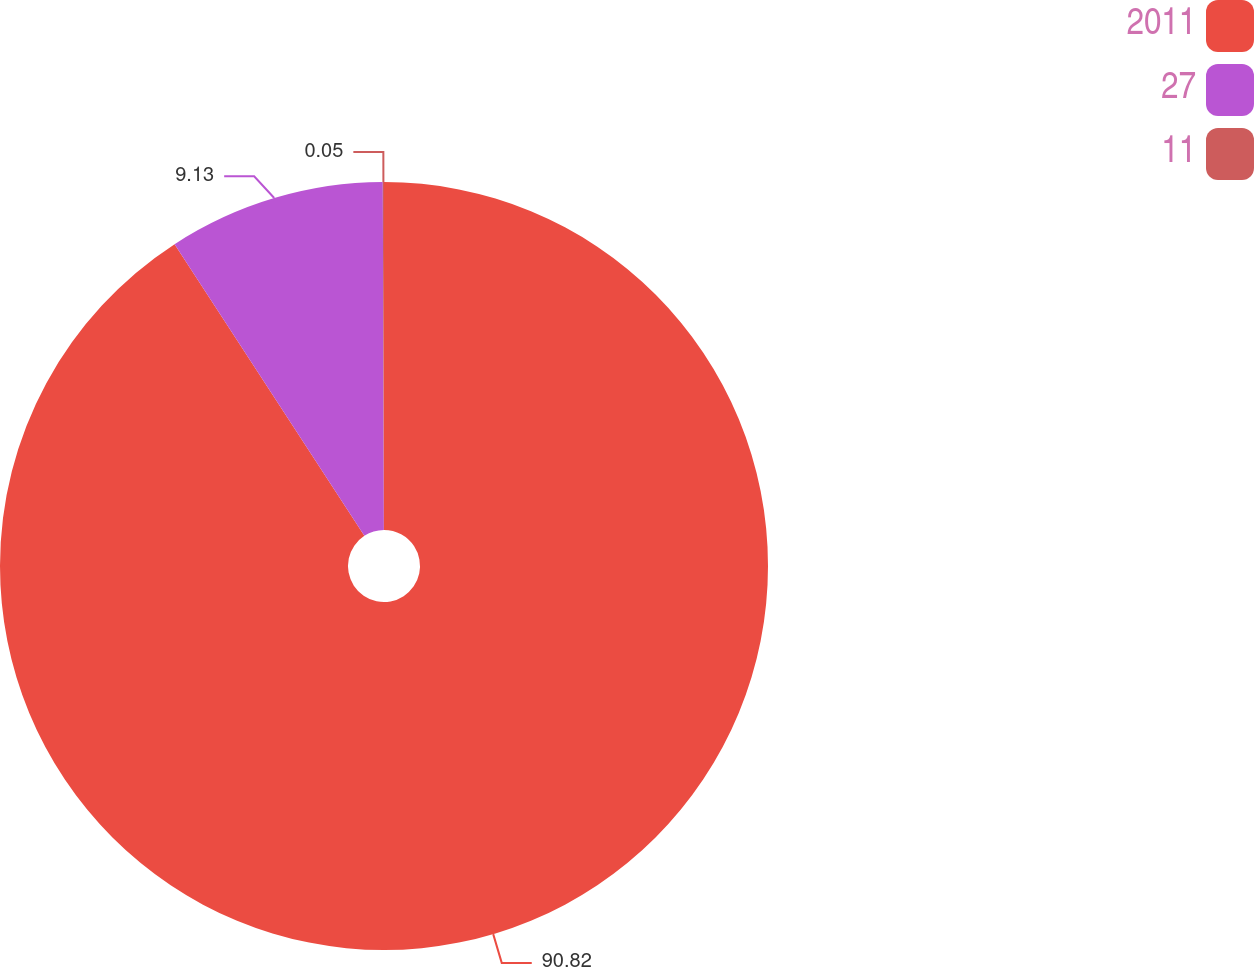<chart> <loc_0><loc_0><loc_500><loc_500><pie_chart><fcel>2011<fcel>27<fcel>11<nl><fcel>90.82%<fcel>9.13%<fcel>0.05%<nl></chart> 